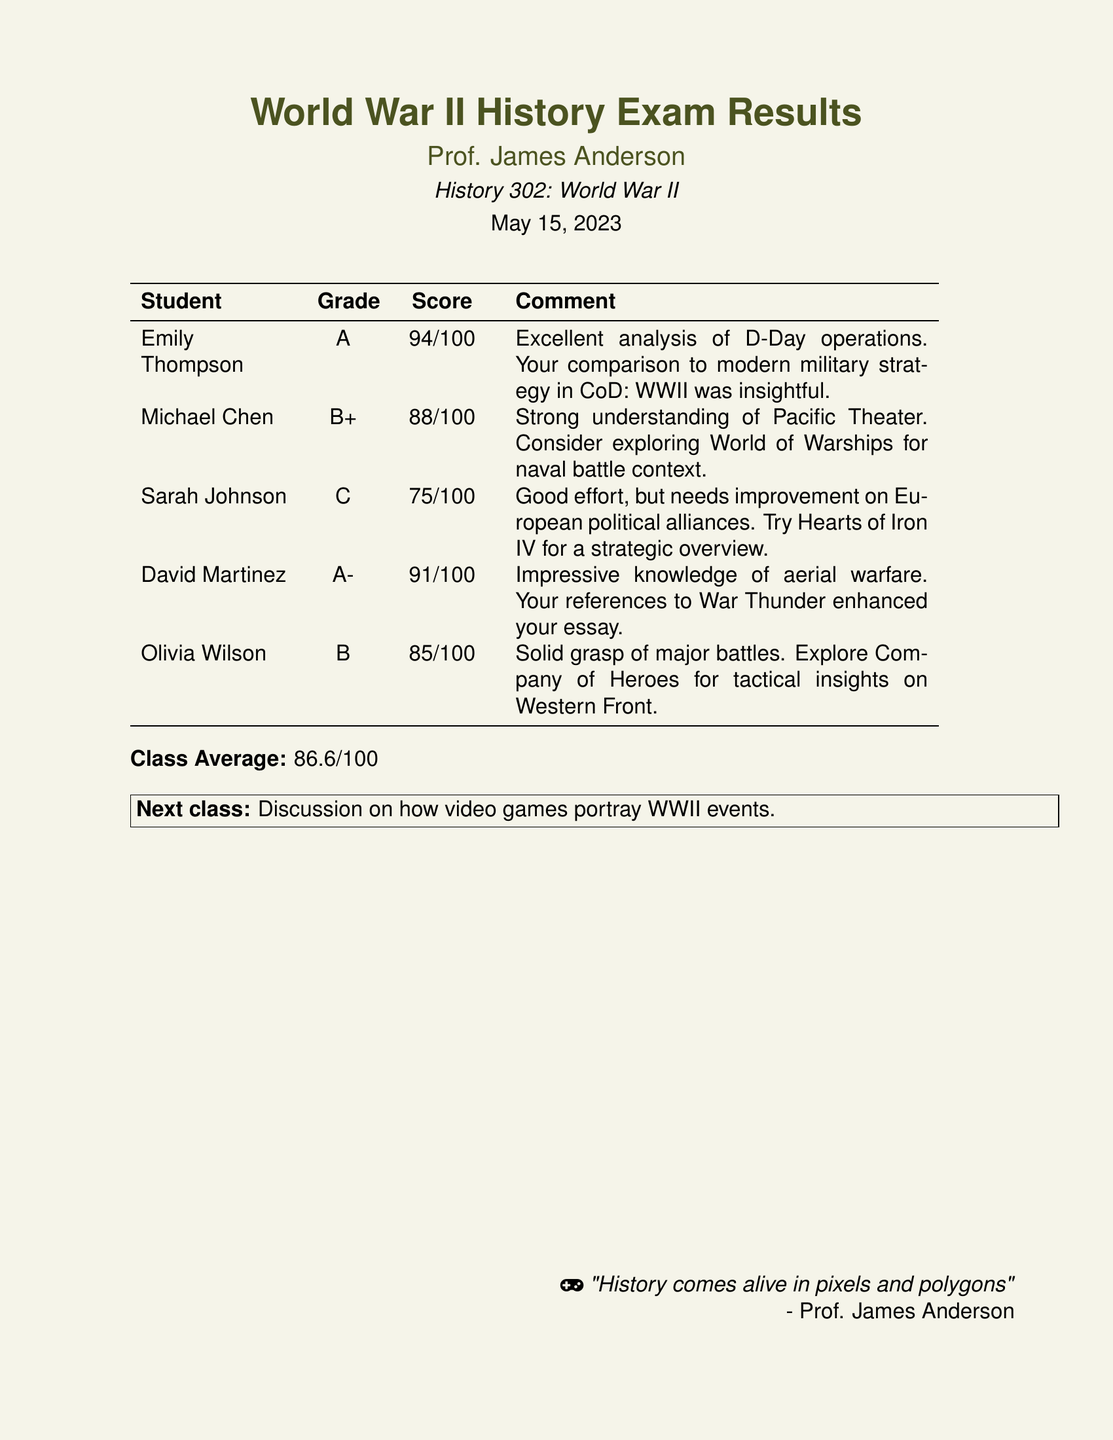What is the highest grade achieved? The highest grade in the document is determined by the grades listed, with Emily Thompson scoring an A.
Answer: A Who received a B+? The document lists Michael Chen as the student who received a B+.
Answer: Michael Chen What was the class average score? The class average is stated at the bottom of the table, explicitly mentioned as 86.6/100.
Answer: 86.6/100 What comment was given to Sarah Johnson? Sarah Johnson's comment is included in the table, specifically noting areas for improvement on alliances.
Answer: Good effort, but needs improvement on European political alliances Which student had the lowest score? The lowest score can be retrieved from the scores listed, with Sarah Johnson scoring 75/100.
Answer: Sarah Johnson 